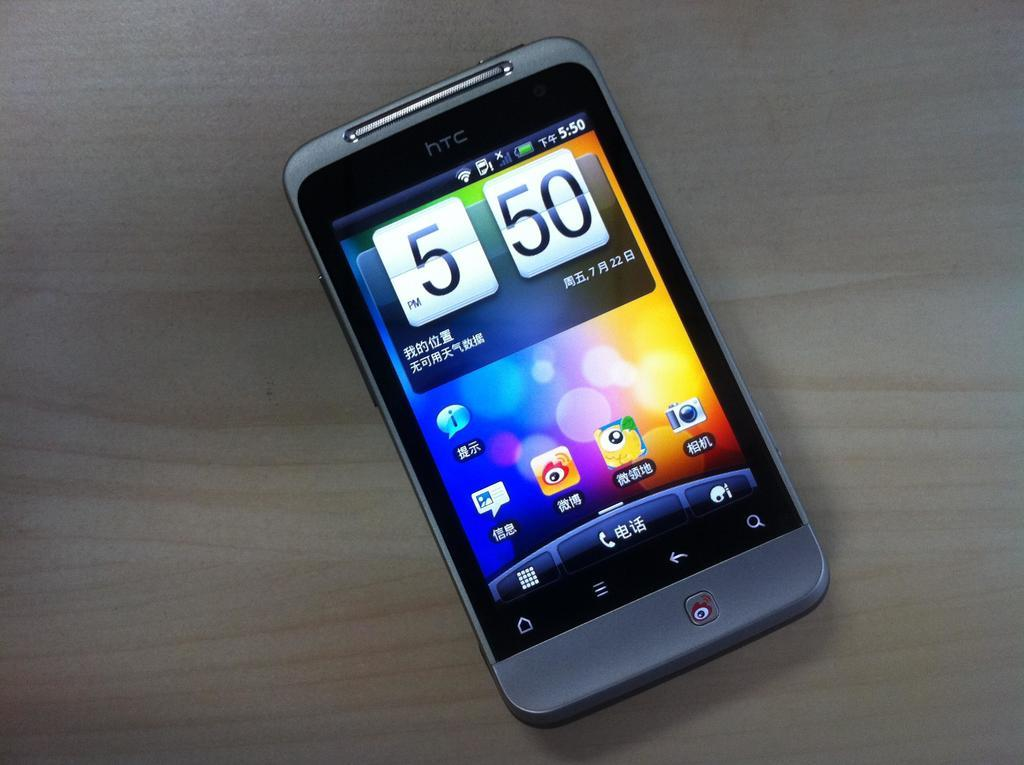Provide a one-sentence caption for the provided image. A cell phone shows that it is 5:50 p.m. 